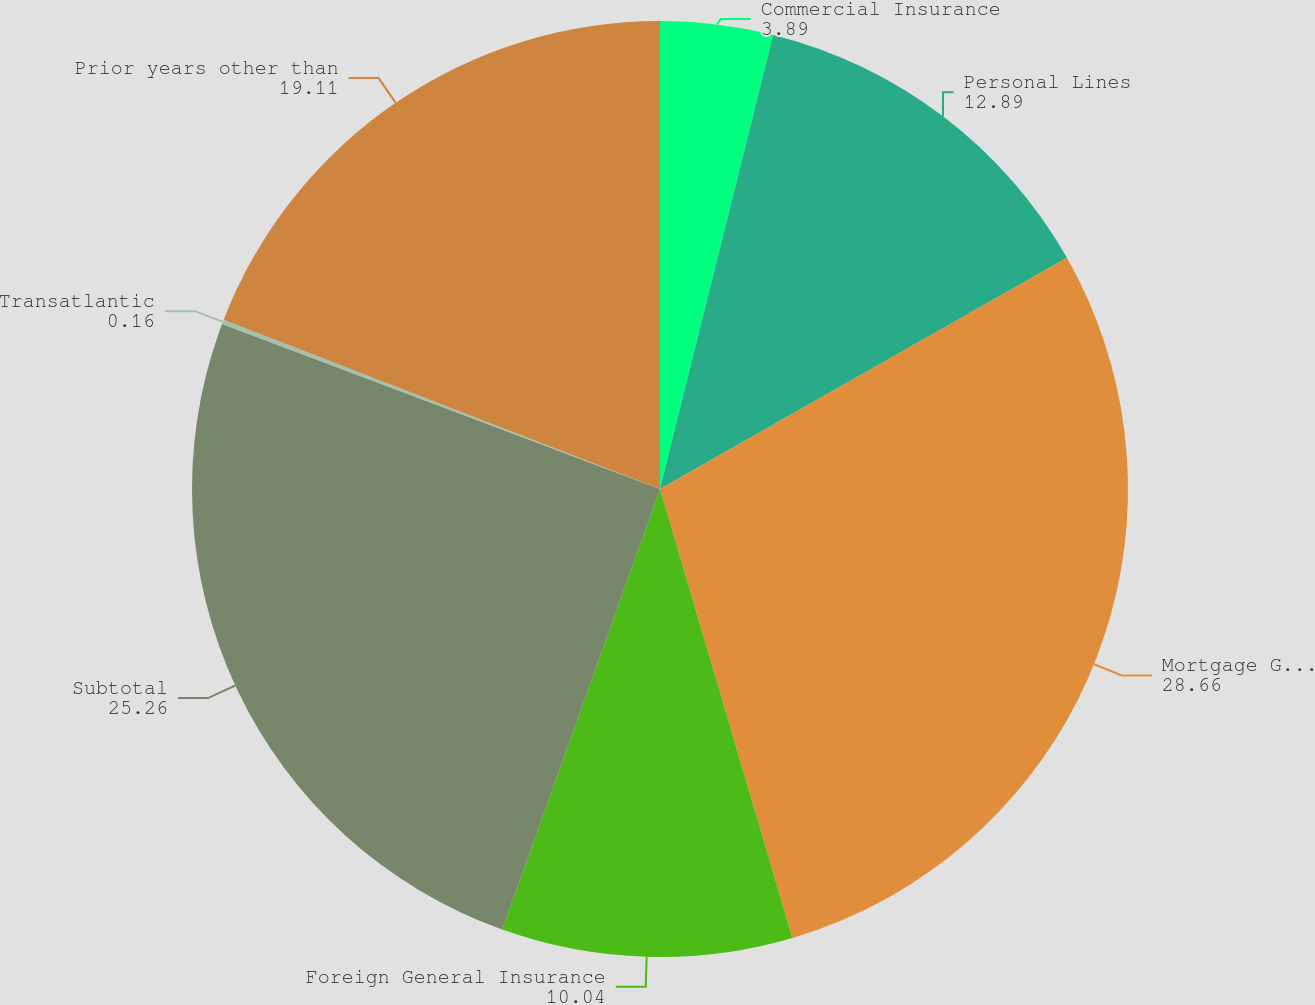Convert chart to OTSL. <chart><loc_0><loc_0><loc_500><loc_500><pie_chart><fcel>Commercial Insurance<fcel>Personal Lines<fcel>Mortgage Guaranty<fcel>Foreign General Insurance<fcel>Subtotal<fcel>Transatlantic<fcel>Prior years other than<nl><fcel>3.89%<fcel>12.89%<fcel>28.66%<fcel>10.04%<fcel>25.26%<fcel>0.16%<fcel>19.11%<nl></chart> 